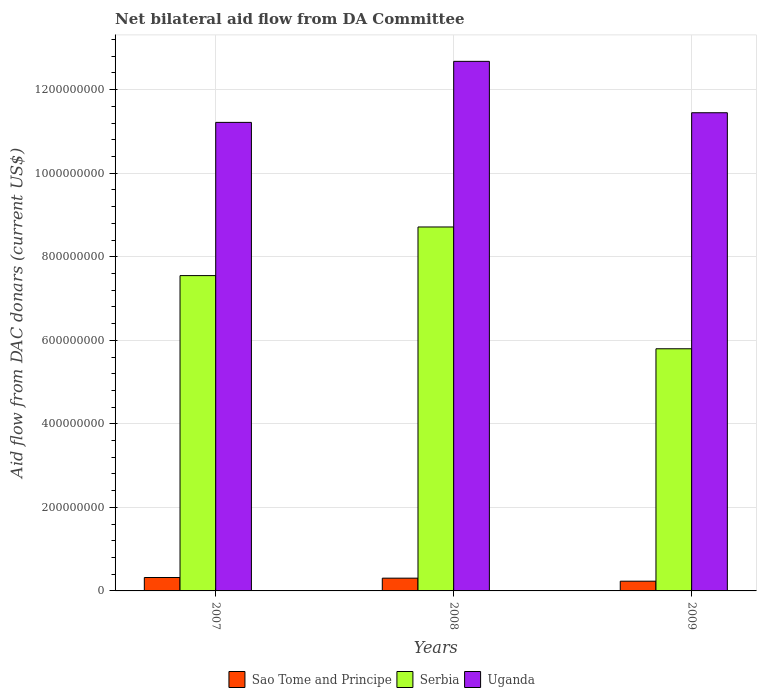How many bars are there on the 3rd tick from the left?
Make the answer very short. 3. What is the aid flow in in Uganda in 2007?
Give a very brief answer. 1.12e+09. Across all years, what is the maximum aid flow in in Sao Tome and Principe?
Keep it short and to the point. 3.21e+07. Across all years, what is the minimum aid flow in in Serbia?
Ensure brevity in your answer.  5.80e+08. What is the total aid flow in in Serbia in the graph?
Offer a terse response. 2.21e+09. What is the difference between the aid flow in in Serbia in 2007 and that in 2008?
Your answer should be compact. -1.16e+08. What is the difference between the aid flow in in Sao Tome and Principe in 2008 and the aid flow in in Serbia in 2009?
Offer a terse response. -5.49e+08. What is the average aid flow in in Serbia per year?
Your answer should be very brief. 7.35e+08. In the year 2009, what is the difference between the aid flow in in Serbia and aid flow in in Uganda?
Your answer should be very brief. -5.65e+08. What is the ratio of the aid flow in in Uganda in 2007 to that in 2009?
Give a very brief answer. 0.98. What is the difference between the highest and the second highest aid flow in in Sao Tome and Principe?
Ensure brevity in your answer.  1.55e+06. What is the difference between the highest and the lowest aid flow in in Uganda?
Offer a very short reply. 1.46e+08. In how many years, is the aid flow in in Sao Tome and Principe greater than the average aid flow in in Sao Tome and Principe taken over all years?
Your answer should be compact. 2. Is the sum of the aid flow in in Sao Tome and Principe in 2007 and 2009 greater than the maximum aid flow in in Serbia across all years?
Your answer should be compact. No. What does the 3rd bar from the left in 2008 represents?
Your response must be concise. Uganda. What does the 1st bar from the right in 2008 represents?
Offer a very short reply. Uganda. Is it the case that in every year, the sum of the aid flow in in Sao Tome and Principe and aid flow in in Serbia is greater than the aid flow in in Uganda?
Make the answer very short. No. How many bars are there?
Keep it short and to the point. 9. Are the values on the major ticks of Y-axis written in scientific E-notation?
Offer a terse response. No. Does the graph contain any zero values?
Keep it short and to the point. No. Does the graph contain grids?
Your answer should be very brief. Yes. Where does the legend appear in the graph?
Keep it short and to the point. Bottom center. What is the title of the graph?
Make the answer very short. Net bilateral aid flow from DA Committee. What is the label or title of the X-axis?
Give a very brief answer. Years. What is the label or title of the Y-axis?
Keep it short and to the point. Aid flow from DAC donars (current US$). What is the Aid flow from DAC donars (current US$) in Sao Tome and Principe in 2007?
Your response must be concise. 3.21e+07. What is the Aid flow from DAC donars (current US$) in Serbia in 2007?
Offer a terse response. 7.55e+08. What is the Aid flow from DAC donars (current US$) in Uganda in 2007?
Keep it short and to the point. 1.12e+09. What is the Aid flow from DAC donars (current US$) of Sao Tome and Principe in 2008?
Keep it short and to the point. 3.06e+07. What is the Aid flow from DAC donars (current US$) in Serbia in 2008?
Your answer should be compact. 8.71e+08. What is the Aid flow from DAC donars (current US$) of Uganda in 2008?
Provide a succinct answer. 1.27e+09. What is the Aid flow from DAC donars (current US$) of Sao Tome and Principe in 2009?
Your response must be concise. 2.33e+07. What is the Aid flow from DAC donars (current US$) in Serbia in 2009?
Give a very brief answer. 5.80e+08. What is the Aid flow from DAC donars (current US$) in Uganda in 2009?
Ensure brevity in your answer.  1.14e+09. Across all years, what is the maximum Aid flow from DAC donars (current US$) of Sao Tome and Principe?
Ensure brevity in your answer.  3.21e+07. Across all years, what is the maximum Aid flow from DAC donars (current US$) in Serbia?
Keep it short and to the point. 8.71e+08. Across all years, what is the maximum Aid flow from DAC donars (current US$) of Uganda?
Make the answer very short. 1.27e+09. Across all years, what is the minimum Aid flow from DAC donars (current US$) of Sao Tome and Principe?
Provide a succinct answer. 2.33e+07. Across all years, what is the minimum Aid flow from DAC donars (current US$) of Serbia?
Provide a short and direct response. 5.80e+08. Across all years, what is the minimum Aid flow from DAC donars (current US$) of Uganda?
Your response must be concise. 1.12e+09. What is the total Aid flow from DAC donars (current US$) of Sao Tome and Principe in the graph?
Make the answer very short. 8.59e+07. What is the total Aid flow from DAC donars (current US$) of Serbia in the graph?
Give a very brief answer. 2.21e+09. What is the total Aid flow from DAC donars (current US$) of Uganda in the graph?
Your answer should be compact. 3.53e+09. What is the difference between the Aid flow from DAC donars (current US$) in Sao Tome and Principe in 2007 and that in 2008?
Make the answer very short. 1.55e+06. What is the difference between the Aid flow from DAC donars (current US$) in Serbia in 2007 and that in 2008?
Ensure brevity in your answer.  -1.16e+08. What is the difference between the Aid flow from DAC donars (current US$) in Uganda in 2007 and that in 2008?
Make the answer very short. -1.46e+08. What is the difference between the Aid flow from DAC donars (current US$) in Sao Tome and Principe in 2007 and that in 2009?
Your response must be concise. 8.84e+06. What is the difference between the Aid flow from DAC donars (current US$) of Serbia in 2007 and that in 2009?
Give a very brief answer. 1.75e+08. What is the difference between the Aid flow from DAC donars (current US$) in Uganda in 2007 and that in 2009?
Offer a very short reply. -2.31e+07. What is the difference between the Aid flow from DAC donars (current US$) in Sao Tome and Principe in 2008 and that in 2009?
Offer a very short reply. 7.29e+06. What is the difference between the Aid flow from DAC donars (current US$) of Serbia in 2008 and that in 2009?
Provide a short and direct response. 2.92e+08. What is the difference between the Aid flow from DAC donars (current US$) in Uganda in 2008 and that in 2009?
Offer a terse response. 1.23e+08. What is the difference between the Aid flow from DAC donars (current US$) of Sao Tome and Principe in 2007 and the Aid flow from DAC donars (current US$) of Serbia in 2008?
Your answer should be compact. -8.39e+08. What is the difference between the Aid flow from DAC donars (current US$) in Sao Tome and Principe in 2007 and the Aid flow from DAC donars (current US$) in Uganda in 2008?
Provide a succinct answer. -1.24e+09. What is the difference between the Aid flow from DAC donars (current US$) in Serbia in 2007 and the Aid flow from DAC donars (current US$) in Uganda in 2008?
Provide a short and direct response. -5.13e+08. What is the difference between the Aid flow from DAC donars (current US$) in Sao Tome and Principe in 2007 and the Aid flow from DAC donars (current US$) in Serbia in 2009?
Give a very brief answer. -5.48e+08. What is the difference between the Aid flow from DAC donars (current US$) in Sao Tome and Principe in 2007 and the Aid flow from DAC donars (current US$) in Uganda in 2009?
Your answer should be very brief. -1.11e+09. What is the difference between the Aid flow from DAC donars (current US$) of Serbia in 2007 and the Aid flow from DAC donars (current US$) of Uganda in 2009?
Give a very brief answer. -3.90e+08. What is the difference between the Aid flow from DAC donars (current US$) of Sao Tome and Principe in 2008 and the Aid flow from DAC donars (current US$) of Serbia in 2009?
Your answer should be very brief. -5.49e+08. What is the difference between the Aid flow from DAC donars (current US$) of Sao Tome and Principe in 2008 and the Aid flow from DAC donars (current US$) of Uganda in 2009?
Your answer should be compact. -1.11e+09. What is the difference between the Aid flow from DAC donars (current US$) of Serbia in 2008 and the Aid flow from DAC donars (current US$) of Uganda in 2009?
Your response must be concise. -2.73e+08. What is the average Aid flow from DAC donars (current US$) in Sao Tome and Principe per year?
Provide a succinct answer. 2.86e+07. What is the average Aid flow from DAC donars (current US$) of Serbia per year?
Your answer should be very brief. 7.35e+08. What is the average Aid flow from DAC donars (current US$) in Uganda per year?
Your answer should be compact. 1.18e+09. In the year 2007, what is the difference between the Aid flow from DAC donars (current US$) of Sao Tome and Principe and Aid flow from DAC donars (current US$) of Serbia?
Ensure brevity in your answer.  -7.23e+08. In the year 2007, what is the difference between the Aid flow from DAC donars (current US$) of Sao Tome and Principe and Aid flow from DAC donars (current US$) of Uganda?
Your response must be concise. -1.09e+09. In the year 2007, what is the difference between the Aid flow from DAC donars (current US$) of Serbia and Aid flow from DAC donars (current US$) of Uganda?
Offer a very short reply. -3.67e+08. In the year 2008, what is the difference between the Aid flow from DAC donars (current US$) of Sao Tome and Principe and Aid flow from DAC donars (current US$) of Serbia?
Make the answer very short. -8.41e+08. In the year 2008, what is the difference between the Aid flow from DAC donars (current US$) of Sao Tome and Principe and Aid flow from DAC donars (current US$) of Uganda?
Ensure brevity in your answer.  -1.24e+09. In the year 2008, what is the difference between the Aid flow from DAC donars (current US$) of Serbia and Aid flow from DAC donars (current US$) of Uganda?
Your answer should be very brief. -3.97e+08. In the year 2009, what is the difference between the Aid flow from DAC donars (current US$) of Sao Tome and Principe and Aid flow from DAC donars (current US$) of Serbia?
Offer a very short reply. -5.56e+08. In the year 2009, what is the difference between the Aid flow from DAC donars (current US$) of Sao Tome and Principe and Aid flow from DAC donars (current US$) of Uganda?
Keep it short and to the point. -1.12e+09. In the year 2009, what is the difference between the Aid flow from DAC donars (current US$) in Serbia and Aid flow from DAC donars (current US$) in Uganda?
Your response must be concise. -5.65e+08. What is the ratio of the Aid flow from DAC donars (current US$) in Sao Tome and Principe in 2007 to that in 2008?
Keep it short and to the point. 1.05. What is the ratio of the Aid flow from DAC donars (current US$) of Serbia in 2007 to that in 2008?
Your answer should be compact. 0.87. What is the ratio of the Aid flow from DAC donars (current US$) in Uganda in 2007 to that in 2008?
Provide a short and direct response. 0.88. What is the ratio of the Aid flow from DAC donars (current US$) in Sao Tome and Principe in 2007 to that in 2009?
Your response must be concise. 1.38. What is the ratio of the Aid flow from DAC donars (current US$) of Serbia in 2007 to that in 2009?
Ensure brevity in your answer.  1.3. What is the ratio of the Aid flow from DAC donars (current US$) of Uganda in 2007 to that in 2009?
Ensure brevity in your answer.  0.98. What is the ratio of the Aid flow from DAC donars (current US$) of Sao Tome and Principe in 2008 to that in 2009?
Give a very brief answer. 1.31. What is the ratio of the Aid flow from DAC donars (current US$) in Serbia in 2008 to that in 2009?
Offer a terse response. 1.5. What is the ratio of the Aid flow from DAC donars (current US$) in Uganda in 2008 to that in 2009?
Your response must be concise. 1.11. What is the difference between the highest and the second highest Aid flow from DAC donars (current US$) in Sao Tome and Principe?
Provide a short and direct response. 1.55e+06. What is the difference between the highest and the second highest Aid flow from DAC donars (current US$) of Serbia?
Make the answer very short. 1.16e+08. What is the difference between the highest and the second highest Aid flow from DAC donars (current US$) of Uganda?
Offer a terse response. 1.23e+08. What is the difference between the highest and the lowest Aid flow from DAC donars (current US$) of Sao Tome and Principe?
Offer a very short reply. 8.84e+06. What is the difference between the highest and the lowest Aid flow from DAC donars (current US$) in Serbia?
Make the answer very short. 2.92e+08. What is the difference between the highest and the lowest Aid flow from DAC donars (current US$) of Uganda?
Keep it short and to the point. 1.46e+08. 